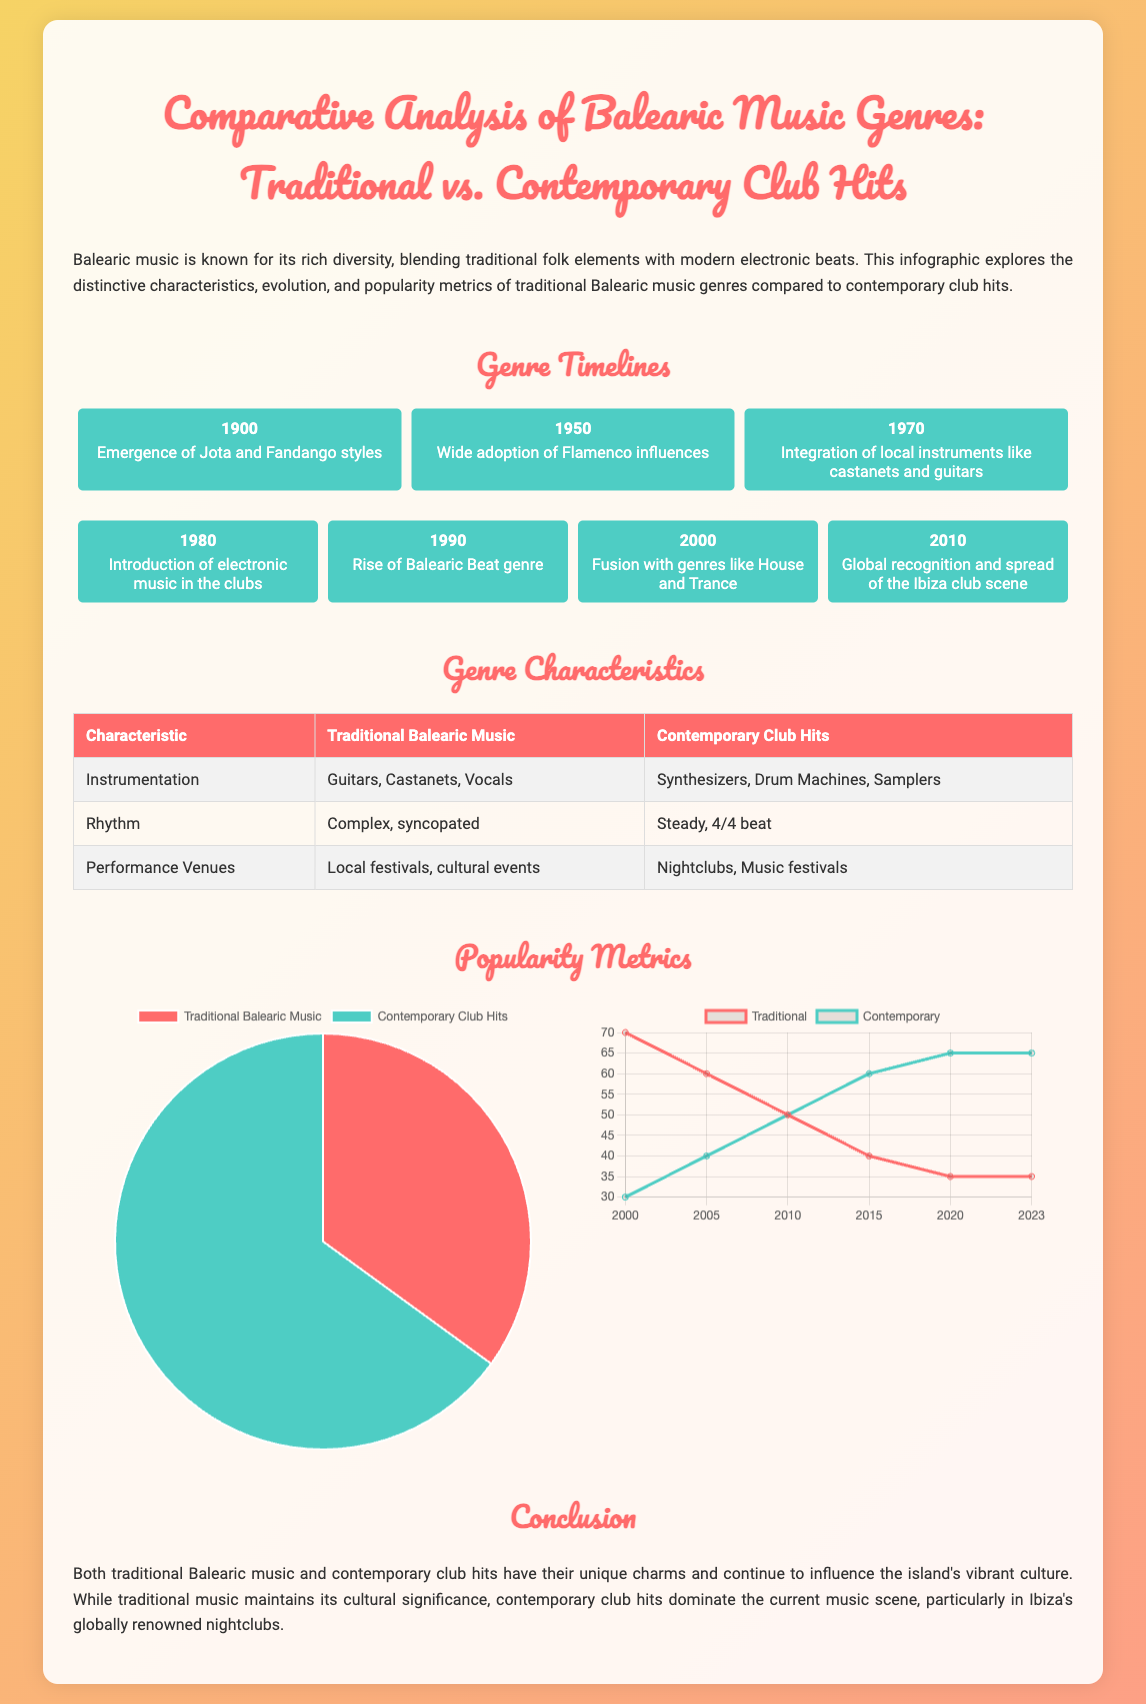what year did the integration of local instruments occur? The timeline shows that the integration of local instruments like castanets and guitars occurred in 1970.
Answer: 1970 which genre saw a rise in the 1990s? The timeline indicates that the rise of the Balearic Beat genre occurred in the 1990s.
Answer: Balearic Beat what are the two main types of music compared in this infographic? The title specifies that the infographic compares Traditional Balearic Music and Contemporary Club Hits.
Answer: Traditional Balearic Music and Contemporary Club Hits how much percentage does contemporary club hits represent in 2023? The pie chart shows that contemporary club hits represent 65% in 2023.
Answer: 65% what is the rhythm characteristic of contemporary club hits? The table states that the rhythm characteristic of contemporary club hits is a steady, 4/4 beat.
Answer: steady, 4/4 beat which genre's popularity has decreased over time according to the line chart? The line chart indicates that the popularity of Traditional Balearic Music has decreased over time.
Answer: Traditional Balearic Music what percentage of traditional Balearic music was popular in 2005? According to the line chart, the popularity of Traditional Balearic Music in 2005 was 60%.
Answer: 60% where are contemporary club hits typically performed? The table states that contemporary club hits are typically performed in nightclubs and music festivals.
Answer: Nightclubs, Music festivals 